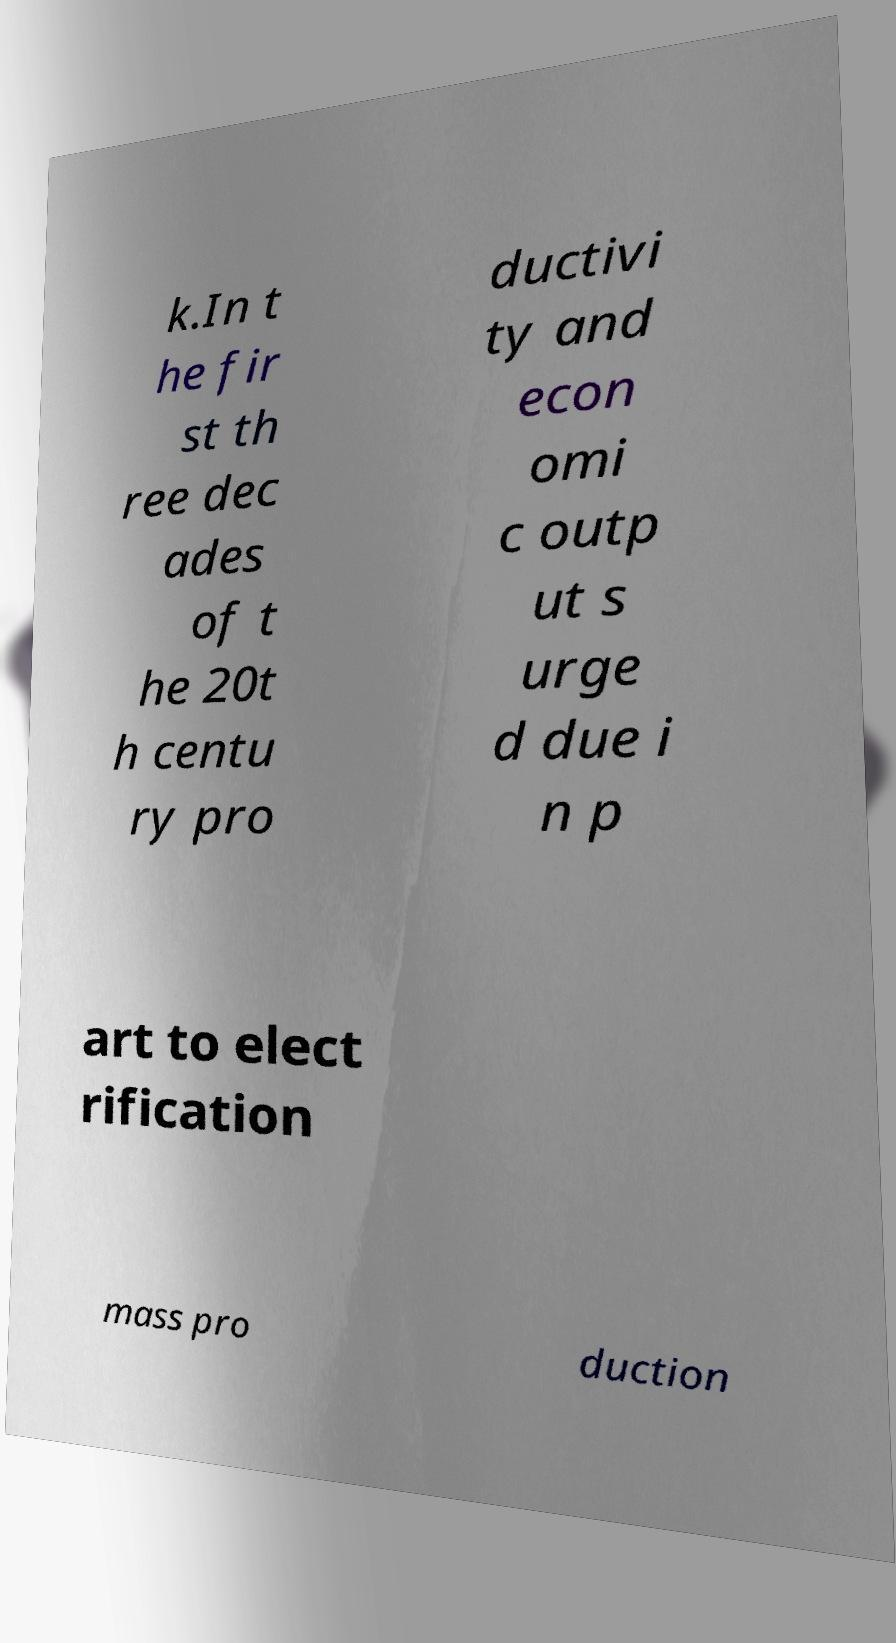I need the written content from this picture converted into text. Can you do that? k.In t he fir st th ree dec ades of t he 20t h centu ry pro ductivi ty and econ omi c outp ut s urge d due i n p art to elect rification mass pro duction 